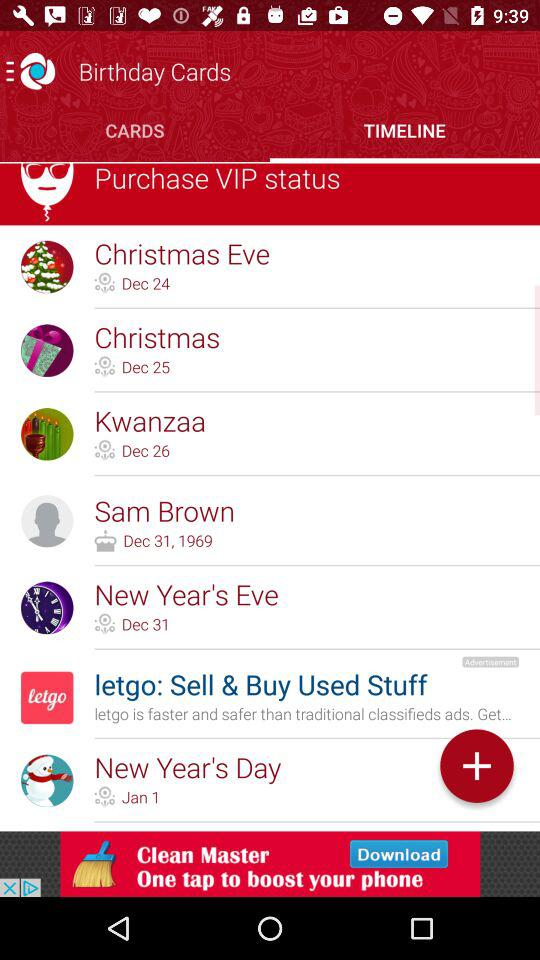What is the new year's eve date? The new year's eve date is December 31. 